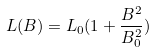<formula> <loc_0><loc_0><loc_500><loc_500>L ( B ) = L _ { 0 } ( 1 + \frac { B ^ { 2 } } { B ^ { 2 } _ { 0 } } )</formula> 